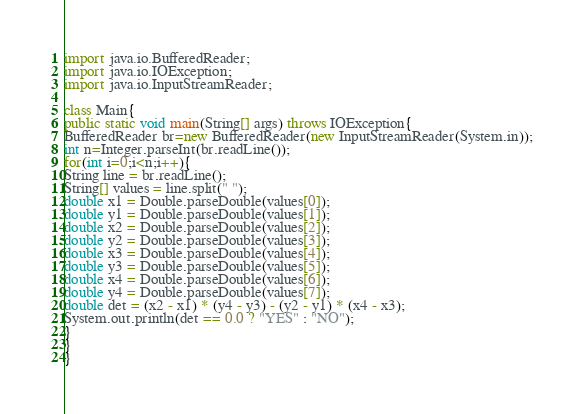<code> <loc_0><loc_0><loc_500><loc_500><_Java_>import java.io.BufferedReader;
import java.io.IOException;
import java.io.InputStreamReader;

class Main{
public static void main(String[] args) throws IOException{
BufferedReader br=new BufferedReader(new InputStreamReader(System.in));
int n=Integer.parseInt(br.readLine());
for(int i=0;i<n;i++){
String line = br.readLine();
String[] values = line.split(" ");
double x1 = Double.parseDouble(values[0]);
double y1 = Double.parseDouble(values[1]);
double x2 = Double.parseDouble(values[2]);
double y2 = Double.parseDouble(values[3]);
double x3 = Double.parseDouble(values[4]);
double y3 = Double.parseDouble(values[5]);
double x4 = Double.parseDouble(values[6]);
double y4 = Double.parseDouble(values[7]);
double det = (x2 - x1) * (y4 - y3) - (y2 - y1) * (x4 - x3);
System.out.println(det == 0.0 ? "YES" : "NO");
}
}
}</code> 